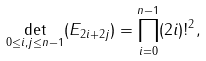<formula> <loc_0><loc_0><loc_500><loc_500>\det _ { 0 \leq i , j \leq n - 1 } ( E _ { 2 i + 2 j } ) = \prod _ { i = 0 } ^ { n - 1 } ( 2 i ) ! ^ { 2 } ,</formula> 